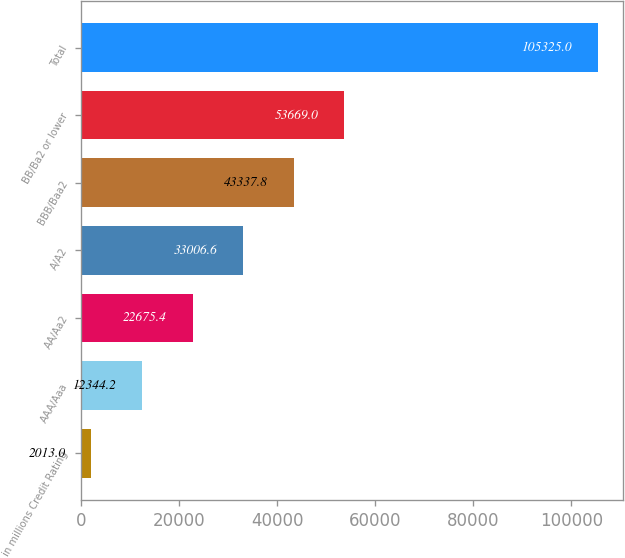Convert chart. <chart><loc_0><loc_0><loc_500><loc_500><bar_chart><fcel>in millions Credit Rating<fcel>AAA/Aaa<fcel>AA/Aa2<fcel>A/A2<fcel>BBB/Baa2<fcel>BB/Ba2 or lower<fcel>Total<nl><fcel>2013<fcel>12344.2<fcel>22675.4<fcel>33006.6<fcel>43337.8<fcel>53669<fcel>105325<nl></chart> 